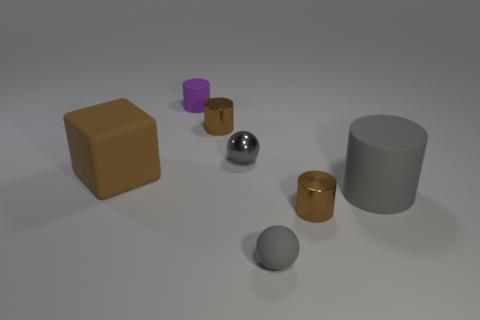What material is the big cylinder that is the same color as the small metal sphere?
Give a very brief answer. Rubber. There is a purple rubber thing; are there any big gray rubber objects on the right side of it?
Provide a short and direct response. Yes. Do the small brown thing that is in front of the large cube and the large gray cylinder have the same material?
Offer a terse response. No. Are there any small cylinders of the same color as the large matte cube?
Provide a succinct answer. Yes. What is the shape of the small gray matte object?
Your answer should be very brief. Sphere. There is a shiny cylinder behind the tiny brown object that is in front of the big rubber cylinder; what color is it?
Provide a succinct answer. Brown. There is a brown object to the left of the tiny purple object; how big is it?
Provide a short and direct response. Large. Is there a tiny block that has the same material as the large gray thing?
Your response must be concise. No. What number of tiny purple things have the same shape as the large gray rubber thing?
Provide a short and direct response. 1. There is a tiny rubber thing that is on the right side of the tiny gray object behind the large matte object that is on the right side of the purple rubber thing; what is its shape?
Provide a succinct answer. Sphere. 